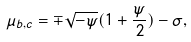<formula> <loc_0><loc_0><loc_500><loc_500>\mu _ { b , c } = \mp \sqrt { - \psi } ( 1 + \frac { \psi } { 2 } ) - \sigma ,</formula> 